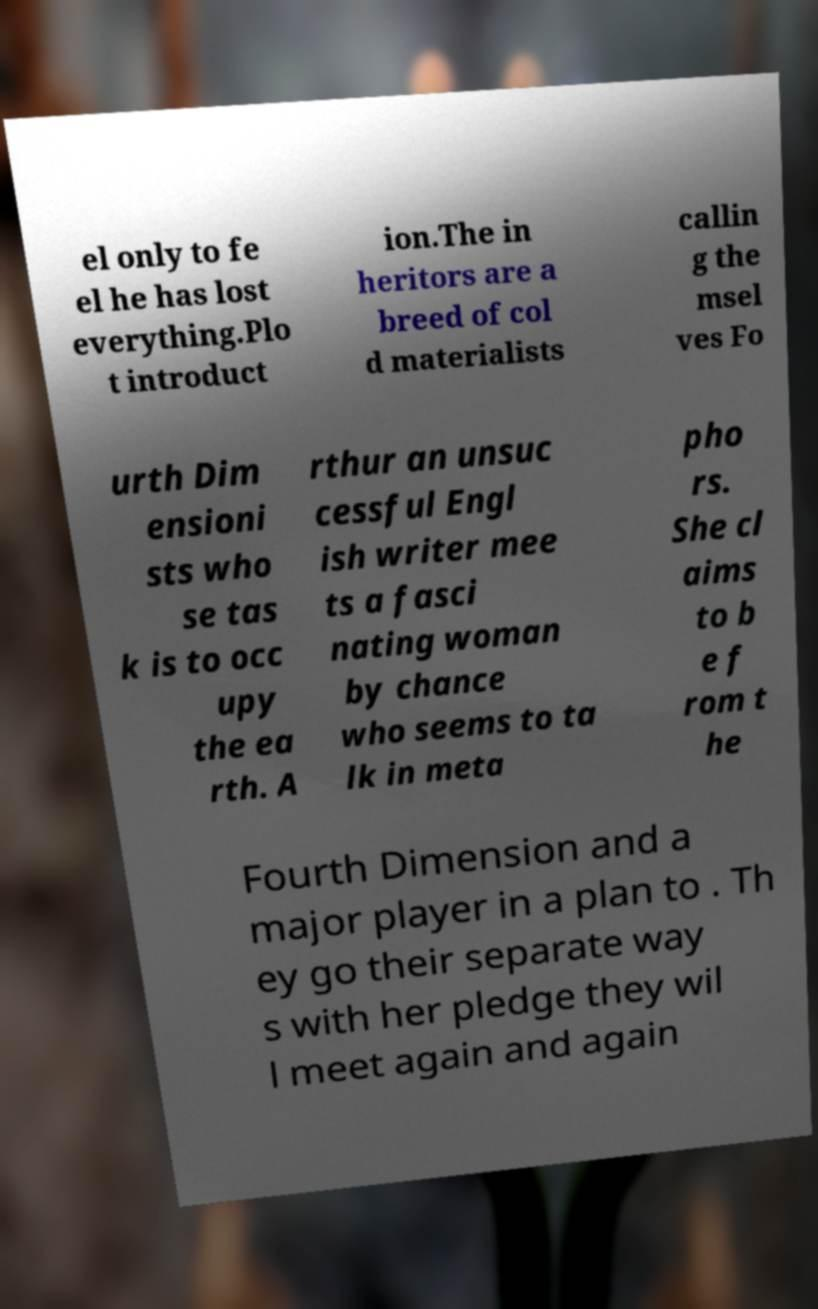Can you accurately transcribe the text from the provided image for me? el only to fe el he has lost everything.Plo t introduct ion.The in heritors are a breed of col d materialists callin g the msel ves Fo urth Dim ensioni sts who se tas k is to occ upy the ea rth. A rthur an unsuc cessful Engl ish writer mee ts a fasci nating woman by chance who seems to ta lk in meta pho rs. She cl aims to b e f rom t he Fourth Dimension and a major player in a plan to . Th ey go their separate way s with her pledge they wil l meet again and again 